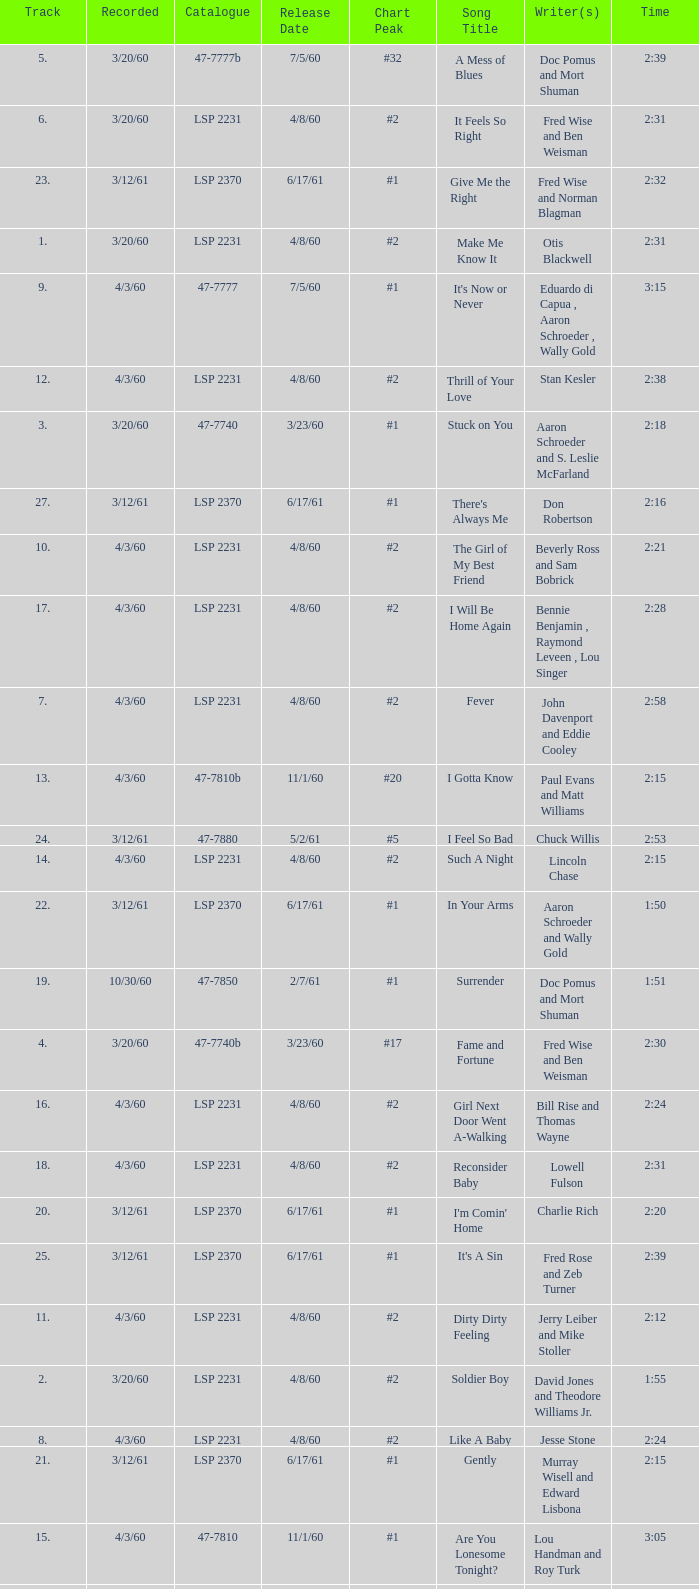What catalogue is the song It's Now or Never? 47-7777. 